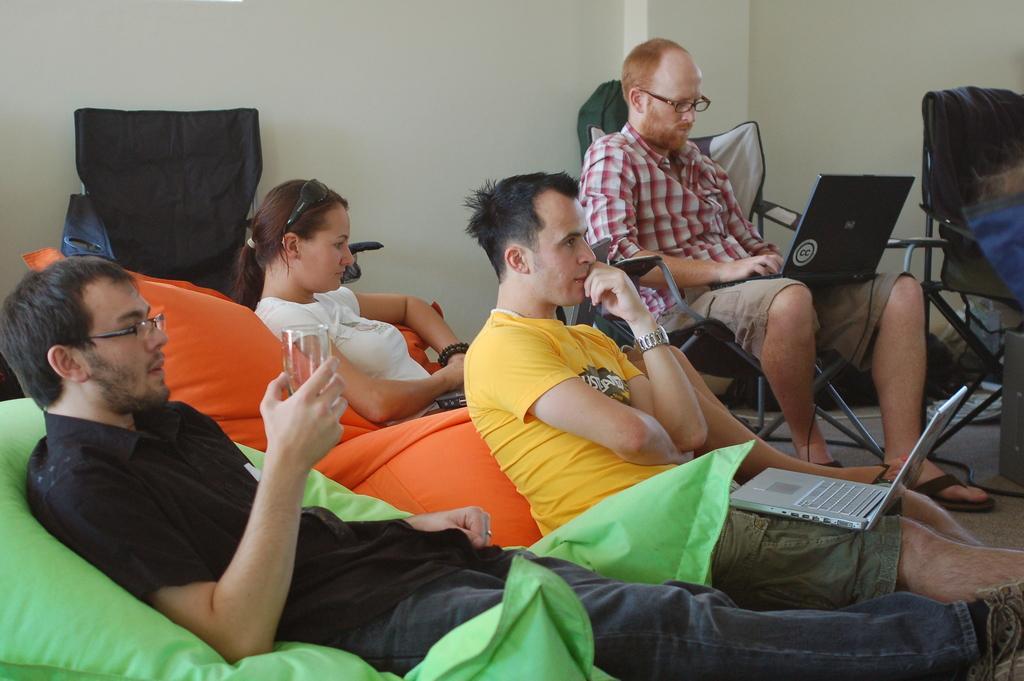Please provide a concise description of this image. In this picture we can see a group of people,one person is holding a glass and in the background we can see a wall. 